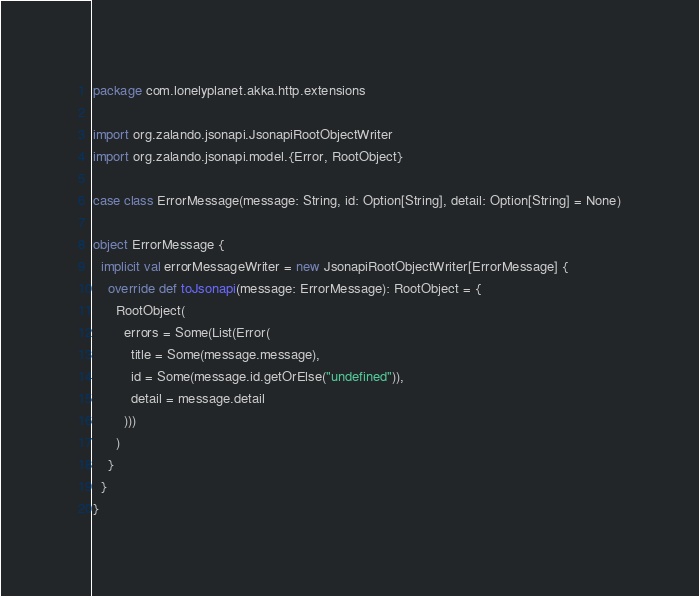<code> <loc_0><loc_0><loc_500><loc_500><_Scala_>package com.lonelyplanet.akka.http.extensions

import org.zalando.jsonapi.JsonapiRootObjectWriter
import org.zalando.jsonapi.model.{Error, RootObject}

case class ErrorMessage(message: String, id: Option[String], detail: Option[String] = None)

object ErrorMessage {
  implicit val errorMessageWriter = new JsonapiRootObjectWriter[ErrorMessage] {
    override def toJsonapi(message: ErrorMessage): RootObject = {
      RootObject(
        errors = Some(List(Error(
          title = Some(message.message),
          id = Some(message.id.getOrElse("undefined")),
          detail = message.detail
        )))
      )
    }
  }
}
</code> 